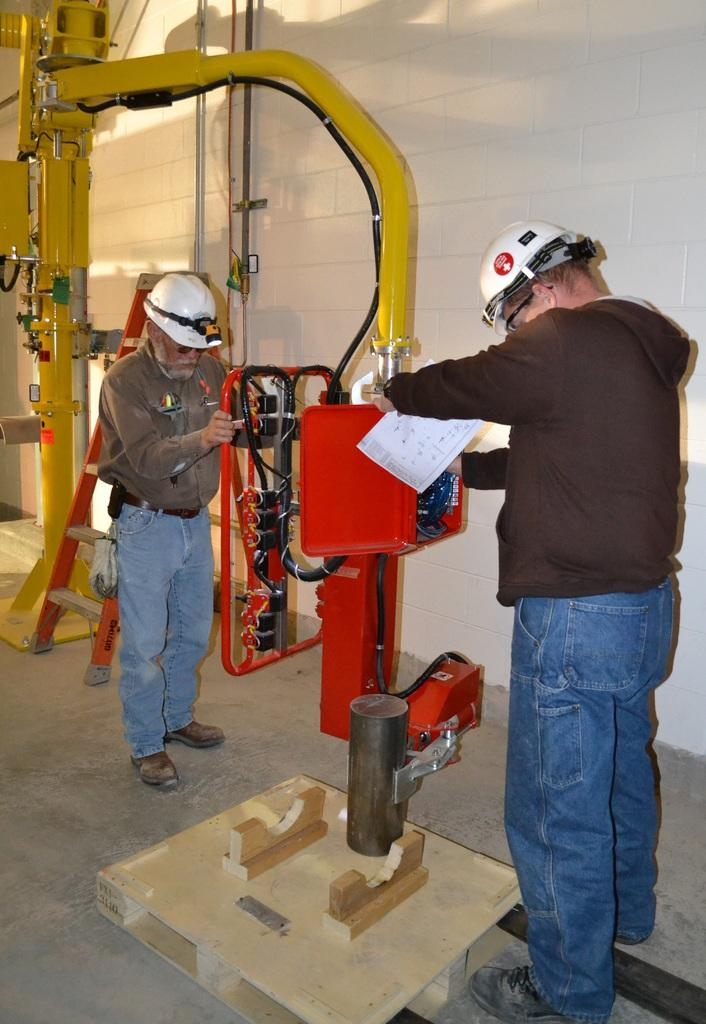How many men are in the image? There are two men in the image. What protective gear are the men wearing? Both men are wearing helmets and goggles. What type of footwear are the men wearing? Both men are wearing shoes. Where are the men standing in the image? The men are standing on the floor. What can be seen in the background of the image? There is a wall in the background of the image. What is the main object in the image besides the men? There is a machine in the image. What type of stitch is being used to create the woolen blanket in the image? There is no woolen blanket or stitching present in the image. What type of crib can be seen in the image? There is no crib present in the image. 